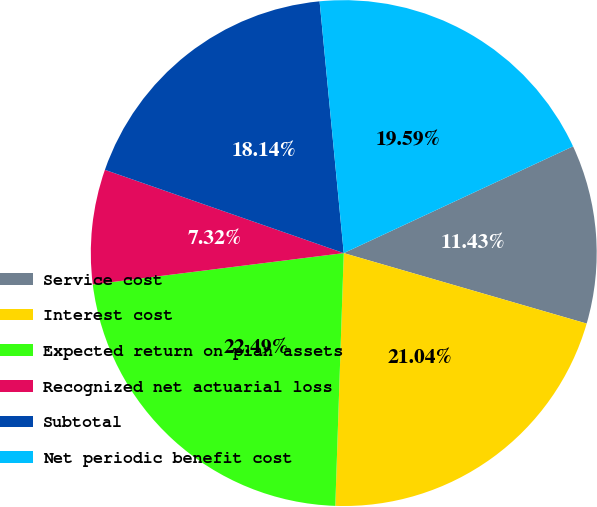Convert chart to OTSL. <chart><loc_0><loc_0><loc_500><loc_500><pie_chart><fcel>Service cost<fcel>Interest cost<fcel>Expected return on plan assets<fcel>Recognized net actuarial loss<fcel>Subtotal<fcel>Net periodic benefit cost<nl><fcel>11.43%<fcel>21.04%<fcel>22.49%<fcel>7.32%<fcel>18.14%<fcel>19.59%<nl></chart> 